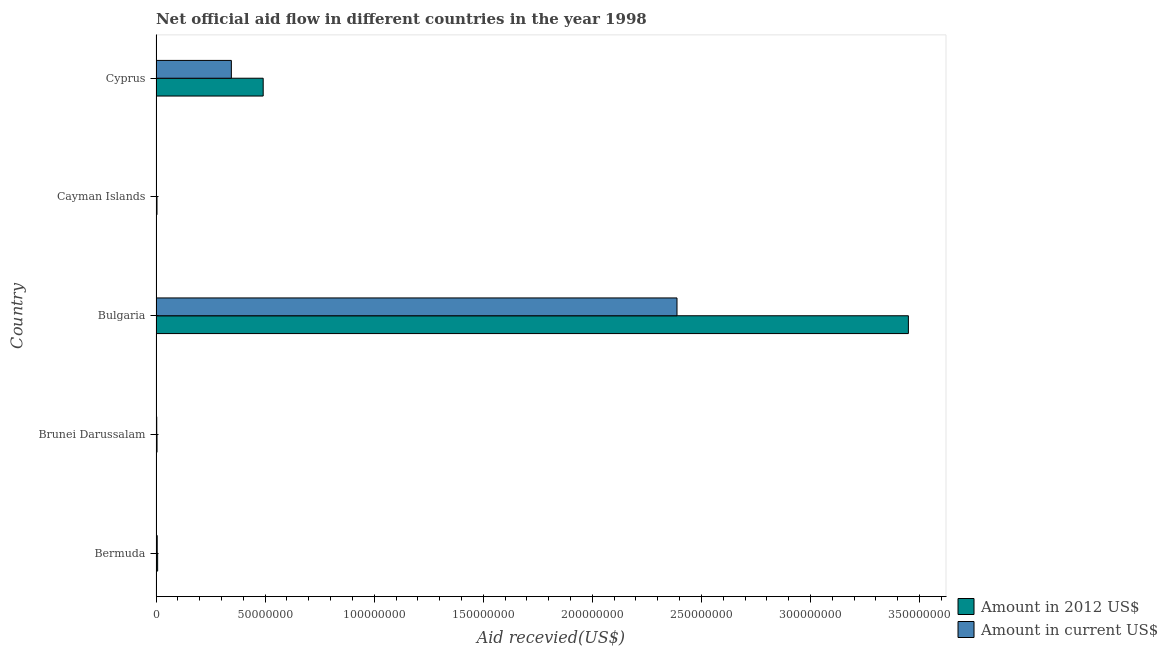How many groups of bars are there?
Ensure brevity in your answer.  5. Are the number of bars per tick equal to the number of legend labels?
Your response must be concise. Yes. How many bars are there on the 4th tick from the top?
Your answer should be compact. 2. How many bars are there on the 5th tick from the bottom?
Offer a very short reply. 2. What is the label of the 5th group of bars from the top?
Provide a short and direct response. Bermuda. What is the amount of aid received(expressed in us$) in Bulgaria?
Provide a short and direct response. 2.39e+08. Across all countries, what is the maximum amount of aid received(expressed in 2012 us$)?
Offer a terse response. 3.45e+08. Across all countries, what is the minimum amount of aid received(expressed in 2012 us$)?
Offer a very short reply. 4.50e+05. In which country was the amount of aid received(expressed in 2012 us$) maximum?
Make the answer very short. Bulgaria. In which country was the amount of aid received(expressed in 2012 us$) minimum?
Your answer should be very brief. Cayman Islands. What is the total amount of aid received(expressed in us$) in the graph?
Make the answer very short. 2.74e+08. What is the difference between the amount of aid received(expressed in 2012 us$) in Bulgaria and that in Cayman Islands?
Give a very brief answer. 3.44e+08. What is the difference between the amount of aid received(expressed in us$) in Bulgaria and the amount of aid received(expressed in 2012 us$) in Cyprus?
Provide a succinct answer. 1.90e+08. What is the average amount of aid received(expressed in us$) per country?
Ensure brevity in your answer.  5.49e+07. What is the difference between the amount of aid received(expressed in 2012 us$) and amount of aid received(expressed in us$) in Bermuda?
Give a very brief answer. 1.90e+05. In how many countries, is the amount of aid received(expressed in 2012 us$) greater than 310000000 US$?
Your response must be concise. 1. What is the ratio of the amount of aid received(expressed in us$) in Brunei Darussalam to that in Bulgaria?
Provide a succinct answer. 0. Is the amount of aid received(expressed in us$) in Bermuda less than that in Brunei Darussalam?
Provide a short and direct response. No. Is the difference between the amount of aid received(expressed in us$) in Brunei Darussalam and Bulgaria greater than the difference between the amount of aid received(expressed in 2012 us$) in Brunei Darussalam and Bulgaria?
Ensure brevity in your answer.  Yes. What is the difference between the highest and the second highest amount of aid received(expressed in 2012 us$)?
Your answer should be compact. 2.96e+08. What is the difference between the highest and the lowest amount of aid received(expressed in 2012 us$)?
Give a very brief answer. 3.44e+08. In how many countries, is the amount of aid received(expressed in us$) greater than the average amount of aid received(expressed in us$) taken over all countries?
Provide a short and direct response. 1. Is the sum of the amount of aid received(expressed in us$) in Brunei Darussalam and Cayman Islands greater than the maximum amount of aid received(expressed in 2012 us$) across all countries?
Your answer should be very brief. No. What does the 1st bar from the top in Bulgaria represents?
Keep it short and to the point. Amount in current US$. What does the 1st bar from the bottom in Bulgaria represents?
Ensure brevity in your answer.  Amount in 2012 US$. How many bars are there?
Keep it short and to the point. 10. Are all the bars in the graph horizontal?
Provide a short and direct response. Yes. Does the graph contain grids?
Provide a short and direct response. No. Where does the legend appear in the graph?
Give a very brief answer. Bottom right. How many legend labels are there?
Your response must be concise. 2. How are the legend labels stacked?
Keep it short and to the point. Vertical. What is the title of the graph?
Your answer should be very brief. Net official aid flow in different countries in the year 1998. Does "Net National savings" appear as one of the legend labels in the graph?
Give a very brief answer. No. What is the label or title of the X-axis?
Provide a short and direct response. Aid recevied(US$). What is the label or title of the Y-axis?
Ensure brevity in your answer.  Country. What is the Aid recevied(US$) in Amount in 2012 US$ in Bermuda?
Provide a succinct answer. 7.40e+05. What is the Aid recevied(US$) in Amount in 2012 US$ in Brunei Darussalam?
Your response must be concise. 4.60e+05. What is the Aid recevied(US$) of Amount in current US$ in Brunei Darussalam?
Make the answer very short. 3.30e+05. What is the Aid recevied(US$) of Amount in 2012 US$ in Bulgaria?
Ensure brevity in your answer.  3.45e+08. What is the Aid recevied(US$) of Amount in current US$ in Bulgaria?
Ensure brevity in your answer.  2.39e+08. What is the Aid recevied(US$) of Amount in 2012 US$ in Cayman Islands?
Provide a succinct answer. 4.50e+05. What is the Aid recevied(US$) of Amount in current US$ in Cayman Islands?
Keep it short and to the point. 1.60e+05. What is the Aid recevied(US$) in Amount in 2012 US$ in Cyprus?
Ensure brevity in your answer.  4.91e+07. What is the Aid recevied(US$) of Amount in current US$ in Cyprus?
Ensure brevity in your answer.  3.45e+07. Across all countries, what is the maximum Aid recevied(US$) in Amount in 2012 US$?
Give a very brief answer. 3.45e+08. Across all countries, what is the maximum Aid recevied(US$) of Amount in current US$?
Provide a succinct answer. 2.39e+08. Across all countries, what is the minimum Aid recevied(US$) of Amount in current US$?
Provide a succinct answer. 1.60e+05. What is the total Aid recevied(US$) of Amount in 2012 US$ in the graph?
Offer a very short reply. 3.96e+08. What is the total Aid recevied(US$) in Amount in current US$ in the graph?
Offer a terse response. 2.74e+08. What is the difference between the Aid recevied(US$) of Amount in current US$ in Bermuda and that in Brunei Darussalam?
Offer a very short reply. 2.20e+05. What is the difference between the Aid recevied(US$) of Amount in 2012 US$ in Bermuda and that in Bulgaria?
Give a very brief answer. -3.44e+08. What is the difference between the Aid recevied(US$) of Amount in current US$ in Bermuda and that in Bulgaria?
Provide a succinct answer. -2.38e+08. What is the difference between the Aid recevied(US$) of Amount in 2012 US$ in Bermuda and that in Cyprus?
Provide a short and direct response. -4.84e+07. What is the difference between the Aid recevied(US$) of Amount in current US$ in Bermuda and that in Cyprus?
Make the answer very short. -3.40e+07. What is the difference between the Aid recevied(US$) of Amount in 2012 US$ in Brunei Darussalam and that in Bulgaria?
Provide a short and direct response. -3.44e+08. What is the difference between the Aid recevied(US$) of Amount in current US$ in Brunei Darussalam and that in Bulgaria?
Your answer should be compact. -2.38e+08. What is the difference between the Aid recevied(US$) in Amount in current US$ in Brunei Darussalam and that in Cayman Islands?
Offer a very short reply. 1.70e+05. What is the difference between the Aid recevied(US$) in Amount in 2012 US$ in Brunei Darussalam and that in Cyprus?
Give a very brief answer. -4.87e+07. What is the difference between the Aid recevied(US$) in Amount in current US$ in Brunei Darussalam and that in Cyprus?
Provide a short and direct response. -3.42e+07. What is the difference between the Aid recevied(US$) in Amount in 2012 US$ in Bulgaria and that in Cayman Islands?
Make the answer very short. 3.44e+08. What is the difference between the Aid recevied(US$) of Amount in current US$ in Bulgaria and that in Cayman Islands?
Offer a very short reply. 2.39e+08. What is the difference between the Aid recevied(US$) of Amount in 2012 US$ in Bulgaria and that in Cyprus?
Provide a succinct answer. 2.96e+08. What is the difference between the Aid recevied(US$) in Amount in current US$ in Bulgaria and that in Cyprus?
Provide a succinct answer. 2.04e+08. What is the difference between the Aid recevied(US$) in Amount in 2012 US$ in Cayman Islands and that in Cyprus?
Offer a terse response. -4.87e+07. What is the difference between the Aid recevied(US$) of Amount in current US$ in Cayman Islands and that in Cyprus?
Offer a terse response. -3.44e+07. What is the difference between the Aid recevied(US$) of Amount in 2012 US$ in Bermuda and the Aid recevied(US$) of Amount in current US$ in Bulgaria?
Your response must be concise. -2.38e+08. What is the difference between the Aid recevied(US$) in Amount in 2012 US$ in Bermuda and the Aid recevied(US$) in Amount in current US$ in Cayman Islands?
Offer a very short reply. 5.80e+05. What is the difference between the Aid recevied(US$) in Amount in 2012 US$ in Bermuda and the Aid recevied(US$) in Amount in current US$ in Cyprus?
Ensure brevity in your answer.  -3.38e+07. What is the difference between the Aid recevied(US$) of Amount in 2012 US$ in Brunei Darussalam and the Aid recevied(US$) of Amount in current US$ in Bulgaria?
Offer a very short reply. -2.38e+08. What is the difference between the Aid recevied(US$) of Amount in 2012 US$ in Brunei Darussalam and the Aid recevied(US$) of Amount in current US$ in Cayman Islands?
Offer a very short reply. 3.00e+05. What is the difference between the Aid recevied(US$) in Amount in 2012 US$ in Brunei Darussalam and the Aid recevied(US$) in Amount in current US$ in Cyprus?
Make the answer very short. -3.41e+07. What is the difference between the Aid recevied(US$) in Amount in 2012 US$ in Bulgaria and the Aid recevied(US$) in Amount in current US$ in Cayman Islands?
Provide a short and direct response. 3.45e+08. What is the difference between the Aid recevied(US$) in Amount in 2012 US$ in Bulgaria and the Aid recevied(US$) in Amount in current US$ in Cyprus?
Give a very brief answer. 3.10e+08. What is the difference between the Aid recevied(US$) in Amount in 2012 US$ in Cayman Islands and the Aid recevied(US$) in Amount in current US$ in Cyprus?
Your answer should be compact. -3.41e+07. What is the average Aid recevied(US$) of Amount in 2012 US$ per country?
Keep it short and to the point. 7.91e+07. What is the average Aid recevied(US$) of Amount in current US$ per country?
Offer a very short reply. 5.49e+07. What is the difference between the Aid recevied(US$) of Amount in 2012 US$ and Aid recevied(US$) of Amount in current US$ in Bermuda?
Your answer should be compact. 1.90e+05. What is the difference between the Aid recevied(US$) of Amount in 2012 US$ and Aid recevied(US$) of Amount in current US$ in Brunei Darussalam?
Your answer should be very brief. 1.30e+05. What is the difference between the Aid recevied(US$) of Amount in 2012 US$ and Aid recevied(US$) of Amount in current US$ in Bulgaria?
Your answer should be compact. 1.06e+08. What is the difference between the Aid recevied(US$) in Amount in 2012 US$ and Aid recevied(US$) in Amount in current US$ in Cayman Islands?
Give a very brief answer. 2.90e+05. What is the difference between the Aid recevied(US$) in Amount in 2012 US$ and Aid recevied(US$) in Amount in current US$ in Cyprus?
Your answer should be very brief. 1.46e+07. What is the ratio of the Aid recevied(US$) of Amount in 2012 US$ in Bermuda to that in Brunei Darussalam?
Provide a succinct answer. 1.61. What is the ratio of the Aid recevied(US$) of Amount in 2012 US$ in Bermuda to that in Bulgaria?
Offer a terse response. 0. What is the ratio of the Aid recevied(US$) of Amount in current US$ in Bermuda to that in Bulgaria?
Make the answer very short. 0. What is the ratio of the Aid recevied(US$) in Amount in 2012 US$ in Bermuda to that in Cayman Islands?
Give a very brief answer. 1.64. What is the ratio of the Aid recevied(US$) in Amount in current US$ in Bermuda to that in Cayman Islands?
Ensure brevity in your answer.  3.44. What is the ratio of the Aid recevied(US$) in Amount in 2012 US$ in Bermuda to that in Cyprus?
Your answer should be compact. 0.02. What is the ratio of the Aid recevied(US$) of Amount in current US$ in Bermuda to that in Cyprus?
Keep it short and to the point. 0.02. What is the ratio of the Aid recevied(US$) of Amount in 2012 US$ in Brunei Darussalam to that in Bulgaria?
Your answer should be compact. 0. What is the ratio of the Aid recevied(US$) of Amount in current US$ in Brunei Darussalam to that in Bulgaria?
Your response must be concise. 0. What is the ratio of the Aid recevied(US$) in Amount in 2012 US$ in Brunei Darussalam to that in Cayman Islands?
Give a very brief answer. 1.02. What is the ratio of the Aid recevied(US$) of Amount in current US$ in Brunei Darussalam to that in Cayman Islands?
Give a very brief answer. 2.06. What is the ratio of the Aid recevied(US$) in Amount in 2012 US$ in Brunei Darussalam to that in Cyprus?
Ensure brevity in your answer.  0.01. What is the ratio of the Aid recevied(US$) in Amount in current US$ in Brunei Darussalam to that in Cyprus?
Offer a very short reply. 0.01. What is the ratio of the Aid recevied(US$) in Amount in 2012 US$ in Bulgaria to that in Cayman Islands?
Offer a very short reply. 766.36. What is the ratio of the Aid recevied(US$) in Amount in current US$ in Bulgaria to that in Cayman Islands?
Ensure brevity in your answer.  1492.5. What is the ratio of the Aid recevied(US$) in Amount in 2012 US$ in Bulgaria to that in Cyprus?
Your answer should be very brief. 7.02. What is the ratio of the Aid recevied(US$) in Amount in current US$ in Bulgaria to that in Cyprus?
Your response must be concise. 6.92. What is the ratio of the Aid recevied(US$) in Amount in 2012 US$ in Cayman Islands to that in Cyprus?
Provide a short and direct response. 0.01. What is the ratio of the Aid recevied(US$) in Amount in current US$ in Cayman Islands to that in Cyprus?
Ensure brevity in your answer.  0. What is the difference between the highest and the second highest Aid recevied(US$) in Amount in 2012 US$?
Provide a succinct answer. 2.96e+08. What is the difference between the highest and the second highest Aid recevied(US$) of Amount in current US$?
Offer a very short reply. 2.04e+08. What is the difference between the highest and the lowest Aid recevied(US$) of Amount in 2012 US$?
Offer a very short reply. 3.44e+08. What is the difference between the highest and the lowest Aid recevied(US$) of Amount in current US$?
Provide a succinct answer. 2.39e+08. 